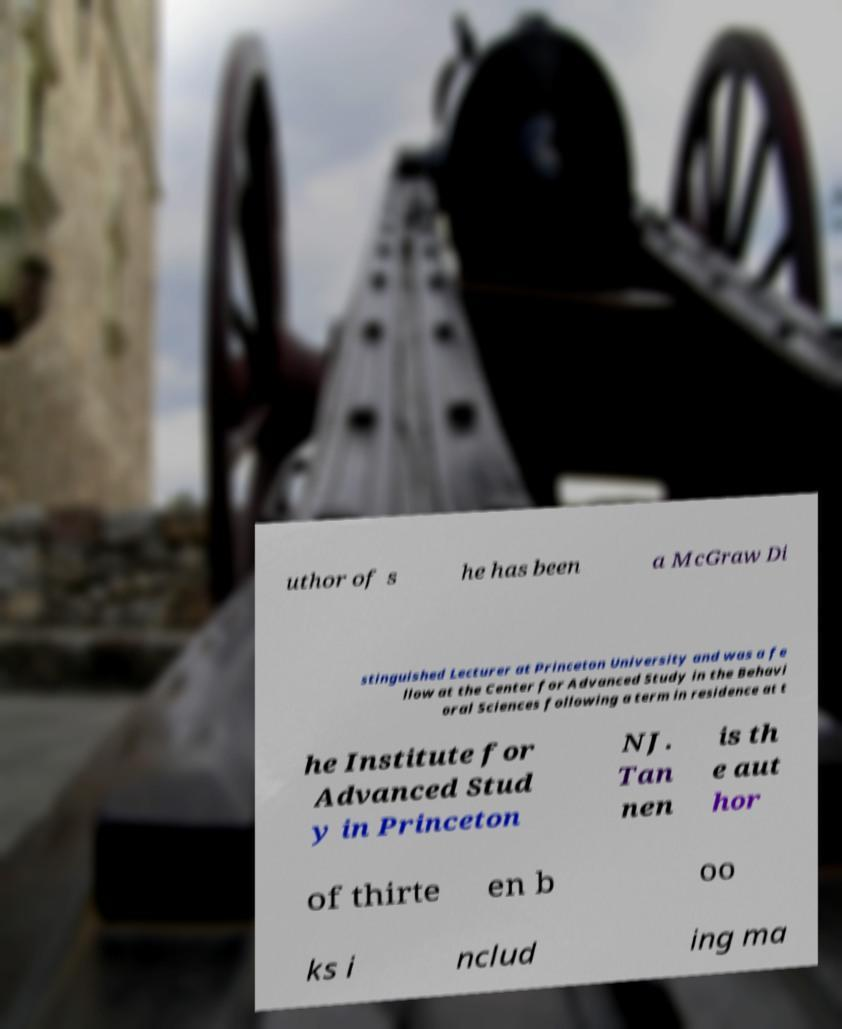Could you assist in decoding the text presented in this image and type it out clearly? uthor of s he has been a McGraw Di stinguished Lecturer at Princeton University and was a fe llow at the Center for Advanced Study in the Behavi oral Sciences following a term in residence at t he Institute for Advanced Stud y in Princeton NJ. Tan nen is th e aut hor of thirte en b oo ks i nclud ing ma 